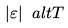<formula> <loc_0><loc_0><loc_500><loc_500>| \varepsilon | \ a l t T</formula> 